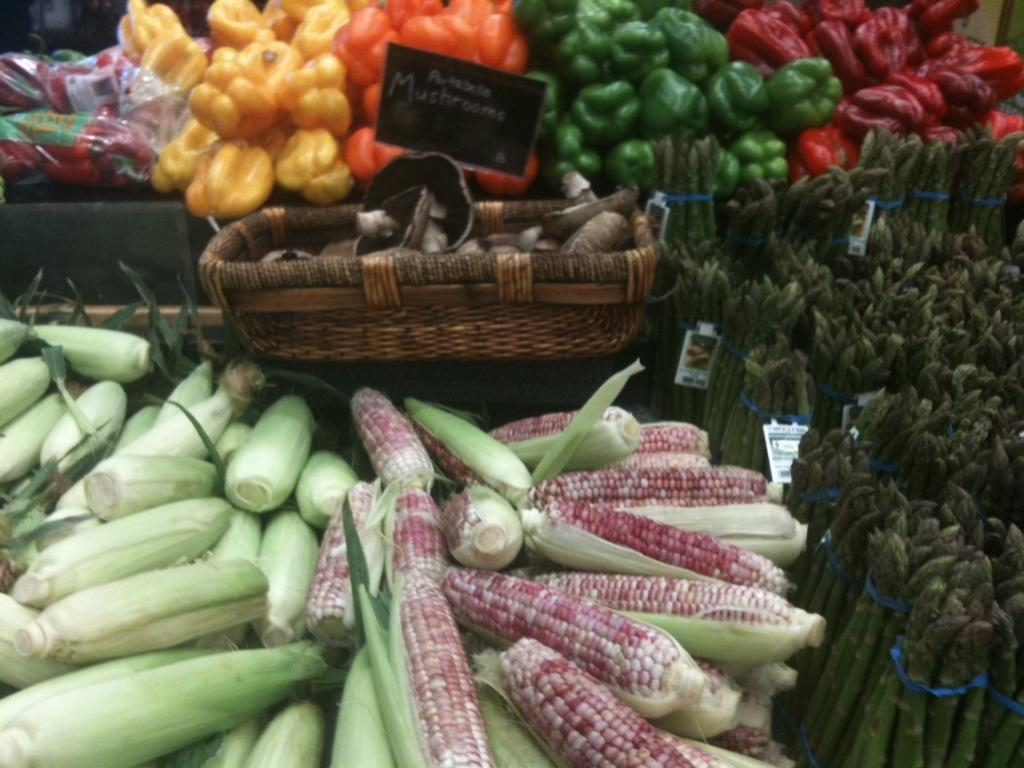What types of food items are visible in the image? There are different types of vegetables in the image. How are the vegetables arranged or displayed in the image? The vegetables may be kept on a table in bulk. What other objects can be seen in the image besides the vegetables? There is a board and a basket in the image. Where might this image have been taken? The image may have been taken in a market. What time of day might this image have been taken? The image may have been taken during the day. What type of lamp is hanging above the vegetables in the image? There is no lamp present in the image; it features different types of vegetables, a board, and a basket. Can you see the father of the vegetable vendor in the image? There is no indication of a vegetable vendor or their family members in the image. 